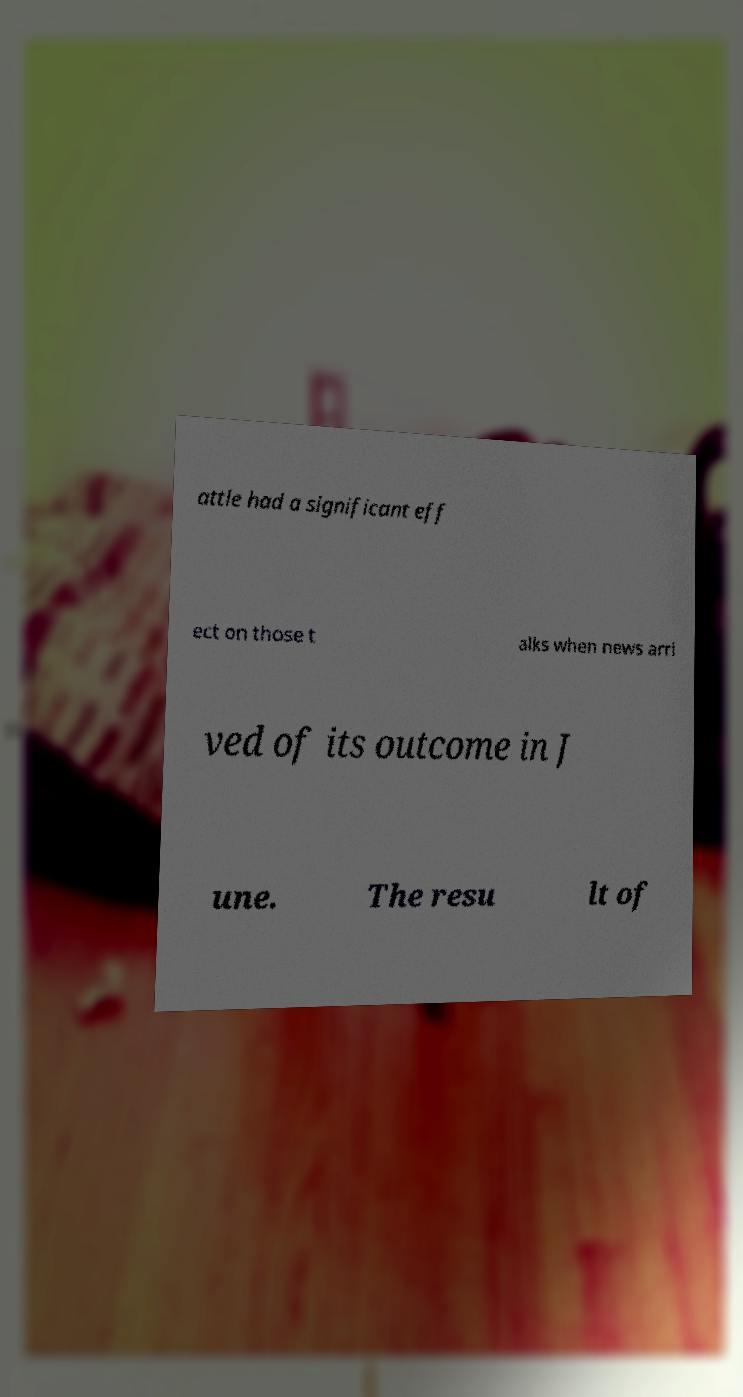Please identify and transcribe the text found in this image. attle had a significant eff ect on those t alks when news arri ved of its outcome in J une. The resu lt of 